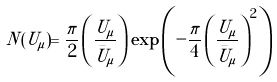Convert formula to latex. <formula><loc_0><loc_0><loc_500><loc_500>N ( U _ { \mu } ) = \frac { \pi } { 2 } \left ( \frac { U _ { \mu } } { \bar { U } _ { \mu } } \right ) \exp \left ( - \frac { \pi } { 4 } \left ( \frac { U _ { \mu } } { \bar { U } _ { \mu } } \right ) ^ { 2 } \right )</formula> 